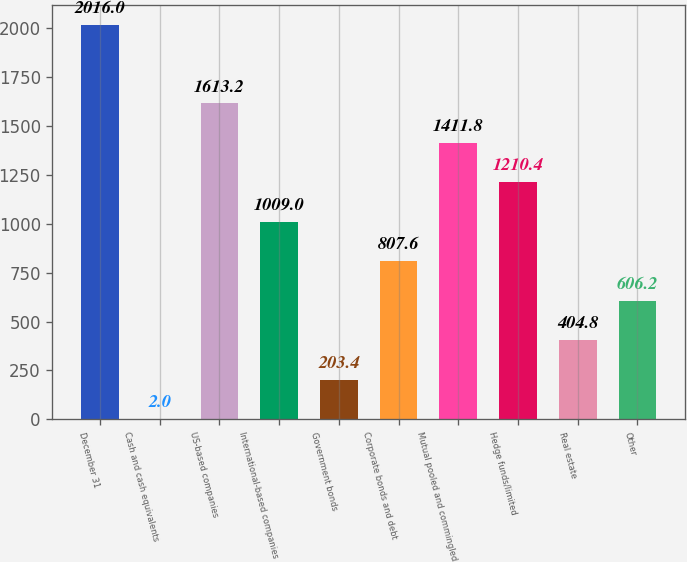<chart> <loc_0><loc_0><loc_500><loc_500><bar_chart><fcel>December 31<fcel>Cash and cash equivalents<fcel>US-based companies<fcel>International-based companies<fcel>Government bonds<fcel>Corporate bonds and debt<fcel>Mutual pooled and commingled<fcel>Hedge funds/limited<fcel>Real estate<fcel>Other<nl><fcel>2016<fcel>2<fcel>1613.2<fcel>1009<fcel>203.4<fcel>807.6<fcel>1411.8<fcel>1210.4<fcel>404.8<fcel>606.2<nl></chart> 